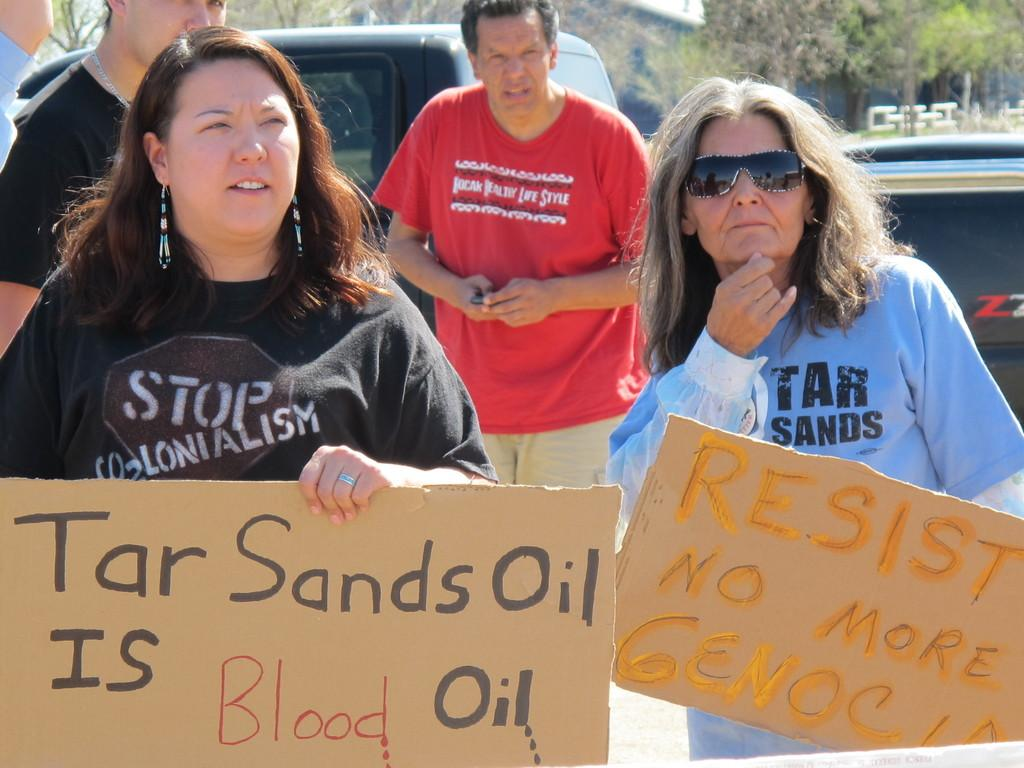What are the two people in the image doing? The two people in the image are holding placards. Are there any other people present in the image? Yes, there are a few other people behind them. What can be seen in the background of the image? Cars and trees are visible in the background of the image. What type of fork can be seen causing destruction in the image? There is no fork present in the image, and no destruction is depicted. 